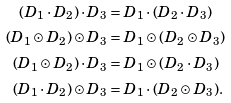Convert formula to latex. <formula><loc_0><loc_0><loc_500><loc_500>( D _ { 1 } \cdot D _ { 2 } ) \cdot D _ { 3 } & = D _ { 1 } \cdot ( D _ { 2 } \cdot D _ { 3 } ) \\ ( D _ { 1 } \odot D _ { 2 } ) \odot D _ { 3 } & = D _ { 1 } \odot ( D _ { 2 } \odot D _ { 3 } ) \\ ( D _ { 1 } \odot D _ { 2 } ) \cdot D _ { 3 } & = D _ { 1 } \odot ( D _ { 2 } \cdot D _ { 3 } ) \\ ( D _ { 1 } \cdot D _ { 2 } ) \odot D _ { 3 } & = D _ { 1 } \cdot ( D _ { 2 } \odot D _ { 3 } ) .</formula> 